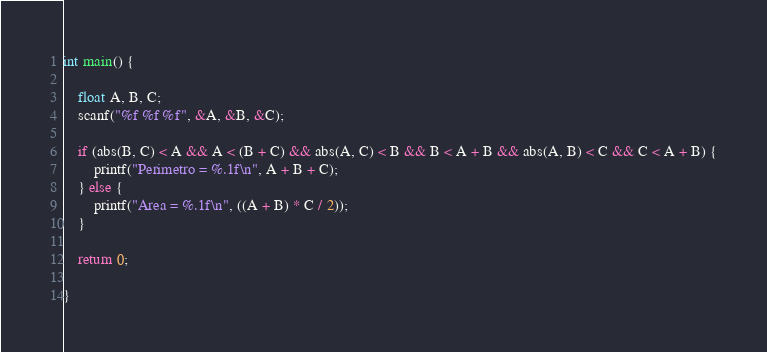<code> <loc_0><loc_0><loc_500><loc_500><_C_>
int main() {

    float A, B, C;
    scanf("%f %f %f", &A, &B, &C);

    if (abs(B, C) < A && A < (B + C) && abs(A, C) < B && B < A + B && abs(A, B) < C && C < A + B) {
        printf("Perimetro = %.1f\n", A + B + C);
    } else {
        printf("Area = %.1f\n", ((A + B) * C / 2));
    }

    return 0;

}</code> 